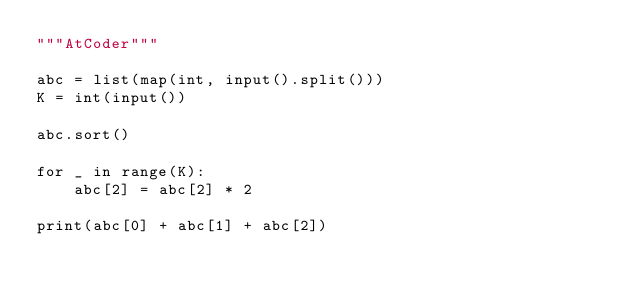<code> <loc_0><loc_0><loc_500><loc_500><_Python_>"""AtCoder"""

abc = list(map(int, input().split()))
K = int(input())

abc.sort()

for _ in range(K):
    abc[2] = abc[2] * 2

print(abc[0] + abc[1] + abc[2])
</code> 